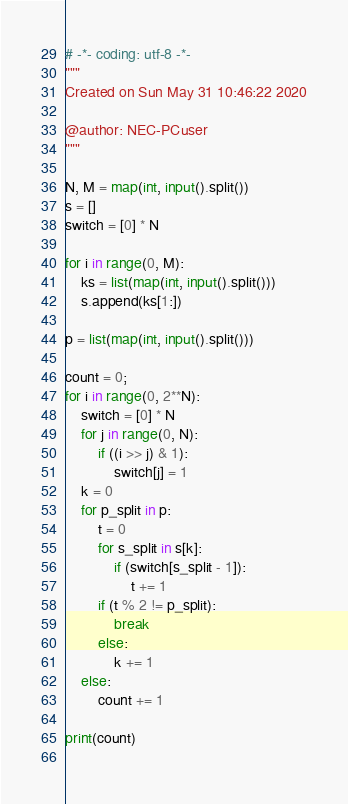<code> <loc_0><loc_0><loc_500><loc_500><_Python_># -*- coding: utf-8 -*-
"""
Created on Sun May 31 10:46:22 2020

@author: NEC-PCuser
"""

N, M = map(int, input().split())
s = []
switch = [0] * N

for i in range(0, M):
    ks = list(map(int, input().split()))
    s.append(ks[1:])

p = list(map(int, input().split()))

count = 0;
for i in range(0, 2**N):
    switch = [0] * N
    for j in range(0, N):
        if ((i >> j) & 1):
            switch[j] = 1
    k = 0
    for p_split in p:
        t = 0
        for s_split in s[k]: 
            if (switch[s_split - 1]):
                t += 1
        if (t % 2 != p_split):
            break
        else:
            k += 1
    else:
        count += 1

print(count)
        </code> 